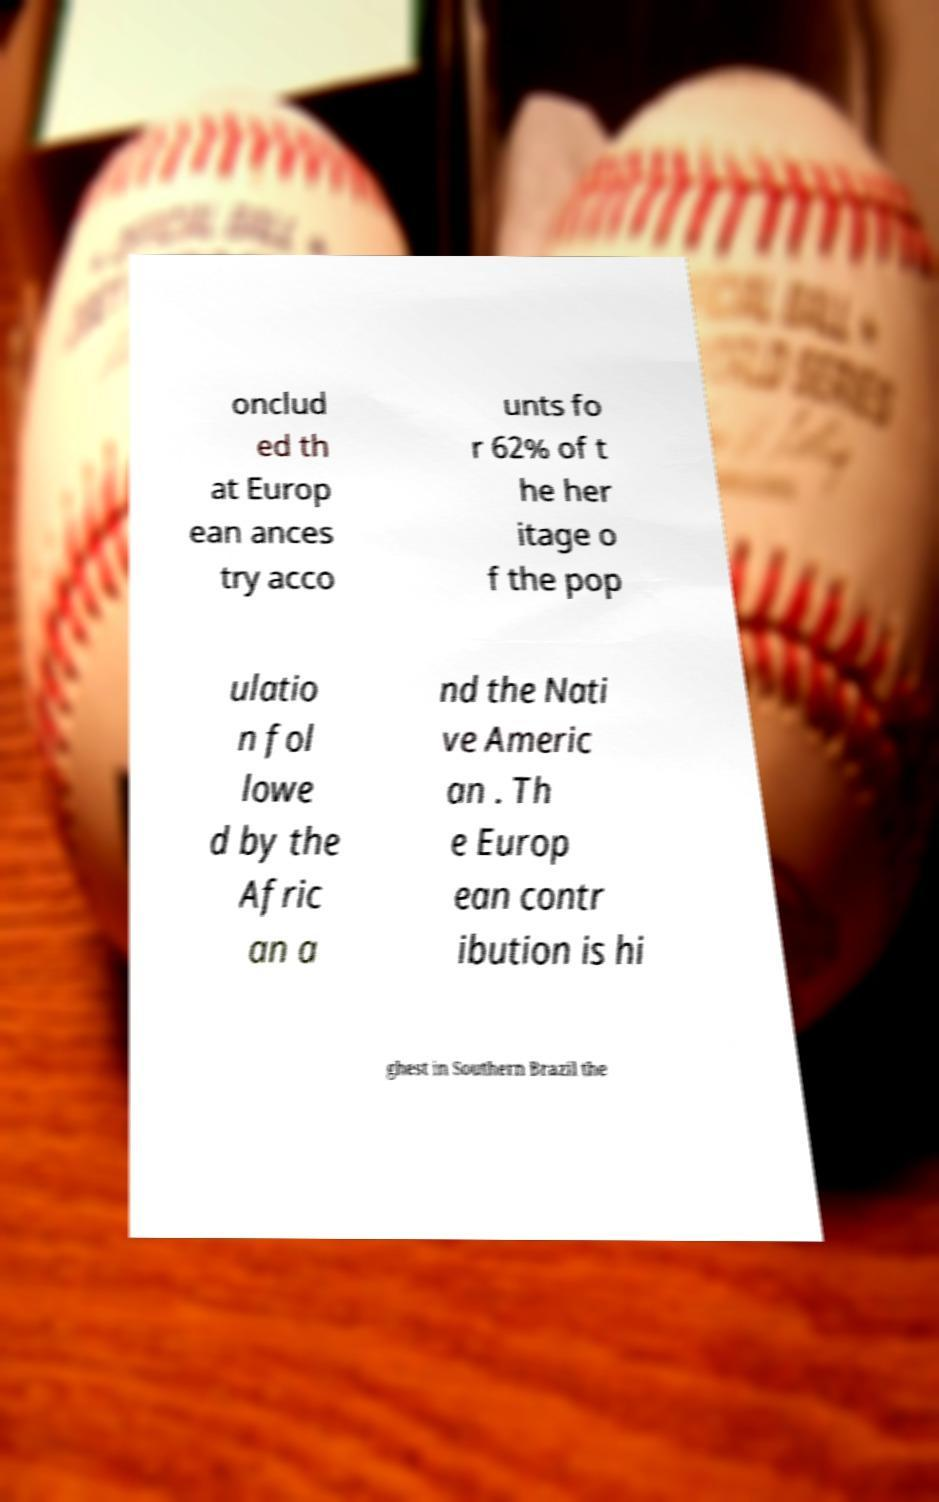Can you read and provide the text displayed in the image?This photo seems to have some interesting text. Can you extract and type it out for me? onclud ed th at Europ ean ances try acco unts fo r 62% of t he her itage o f the pop ulatio n fol lowe d by the Afric an a nd the Nati ve Americ an . Th e Europ ean contr ibution is hi ghest in Southern Brazil the 